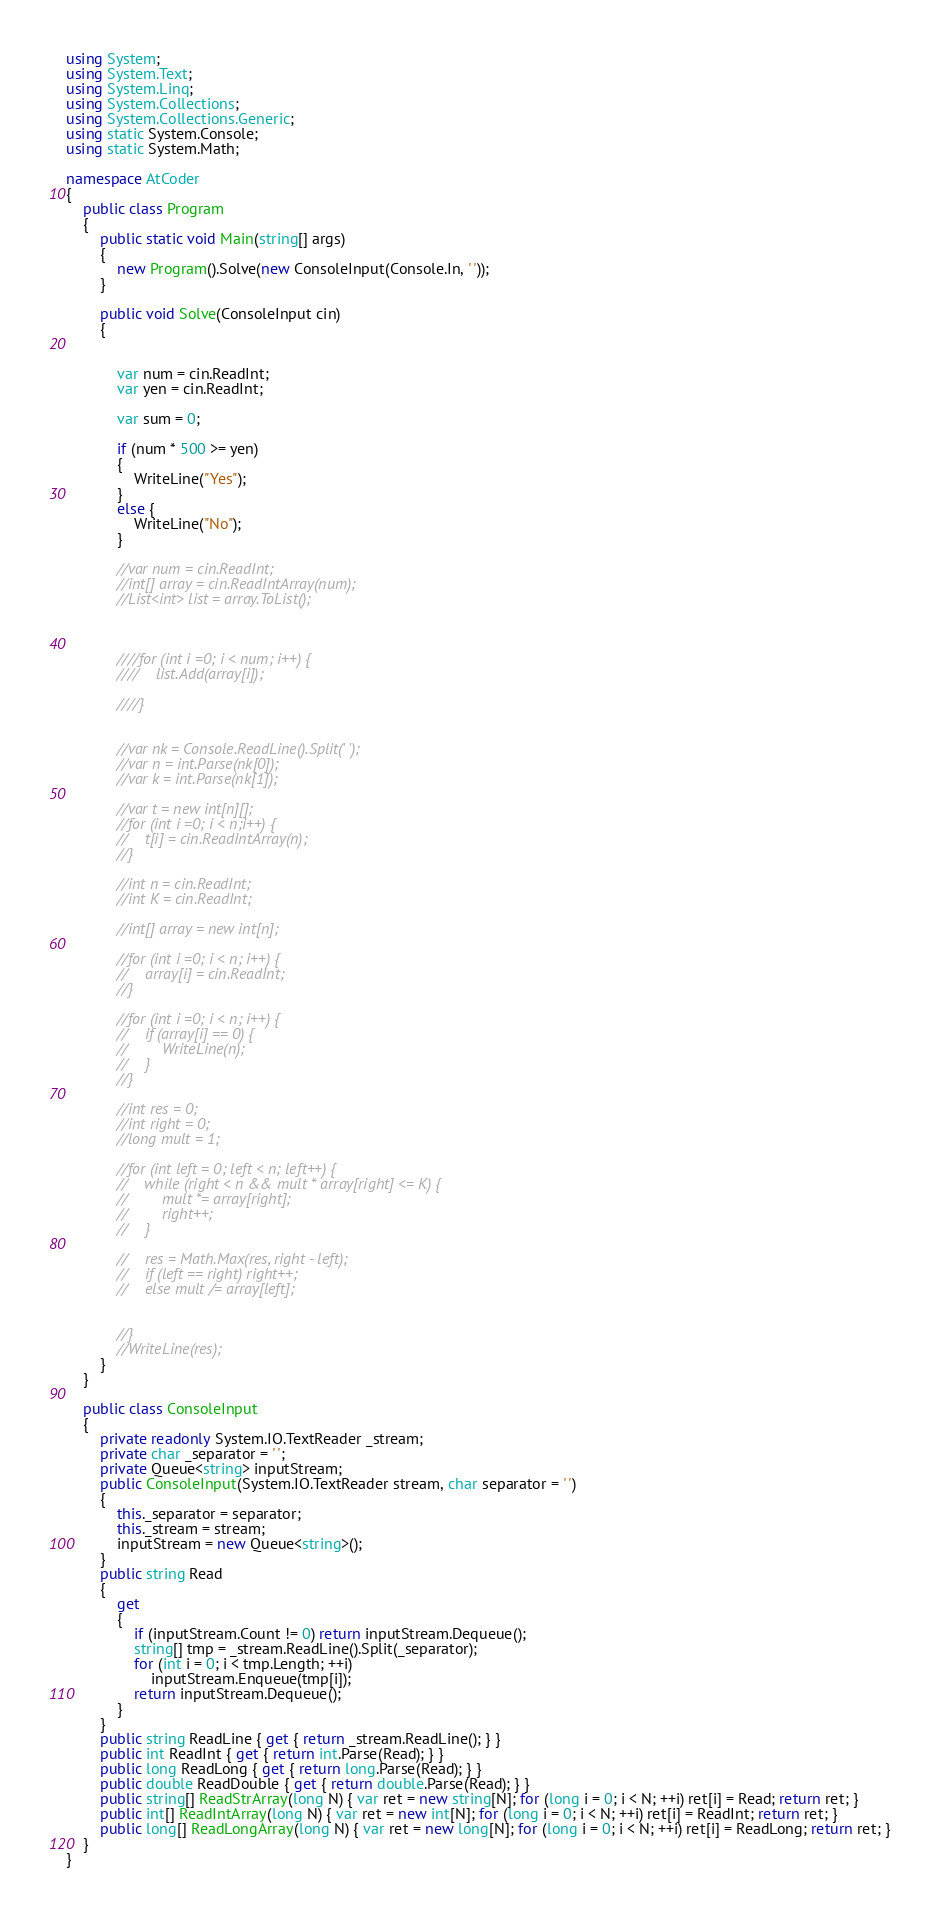<code> <loc_0><loc_0><loc_500><loc_500><_C#_>using System;
using System.Text;
using System.Linq;
using System.Collections;
using System.Collections.Generic;
using static System.Console;
using static System.Math;

namespace AtCoder
{
    public class Program
    {
        public static void Main(string[] args)
        {
            new Program().Solve(new ConsoleInput(Console.In, ' '));
        }

        public void Solve(ConsoleInput cin)
        {


            var num = cin.ReadInt;
            var yen = cin.ReadInt;

            var sum = 0;

            if (num * 500 >= yen)
            {
                WriteLine("Yes");
            }
            else {
                WriteLine("No");
            }

            //var num = cin.ReadInt;
            //int[] array = cin.ReadIntArray(num);
            //List<int> list = array.ToList();



            ////for (int i =0; i < num; i++) {
            ////    list.Add(array[i]);

            ////}


            //var nk = Console.ReadLine().Split(' ');
            //var n = int.Parse(nk[0]);
            //var k = int.Parse(nk[1]);

            //var t = new int[n][];
            //for (int i =0; i < n;i++) {
            //    t[i] = cin.ReadIntArray(n);
            //}

            //int n = cin.ReadInt;
            //int K = cin.ReadInt;

            //int[] array = new int[n];

            //for (int i =0; i < n; i++) {
            //    array[i] = cin.ReadInt;
            //}

            //for (int i =0; i < n; i++) {
            //    if (array[i] == 0) {
            //        WriteLine(n);
            //    }
            //}

            //int res = 0;
            //int right = 0;
            //long mult = 1;

            //for (int left = 0; left < n; left++) {
            //    while (right < n && mult * array[right] <= K) {
            //        mult *= array[right];
            //        right++;
            //    }

            //    res = Math.Max(res, right - left);
            //    if (left == right) right++;
            //    else mult /= array[left];


            //}
            //WriteLine(res);
        }
    }

    public class ConsoleInput
    {
        private readonly System.IO.TextReader _stream;
        private char _separator = ' ';
        private Queue<string> inputStream;
        public ConsoleInput(System.IO.TextReader stream, char separator = ' ')
        {
            this._separator = separator;
            this._stream = stream;
            inputStream = new Queue<string>();
        }
        public string Read
        {
            get
            {
                if (inputStream.Count != 0) return inputStream.Dequeue();
                string[] tmp = _stream.ReadLine().Split(_separator);
                for (int i = 0; i < tmp.Length; ++i)
                    inputStream.Enqueue(tmp[i]);
                return inputStream.Dequeue();
            }
        }
        public string ReadLine { get { return _stream.ReadLine(); } }
        public int ReadInt { get { return int.Parse(Read); } }
        public long ReadLong { get { return long.Parse(Read); } }
        public double ReadDouble { get { return double.Parse(Read); } }
        public string[] ReadStrArray(long N) { var ret = new string[N]; for (long i = 0; i < N; ++i) ret[i] = Read; return ret; }
        public int[] ReadIntArray(long N) { var ret = new int[N]; for (long i = 0; i < N; ++i) ret[i] = ReadInt; return ret; }
        public long[] ReadLongArray(long N) { var ret = new long[N]; for (long i = 0; i < N; ++i) ret[i] = ReadLong; return ret; }
    }
}</code> 